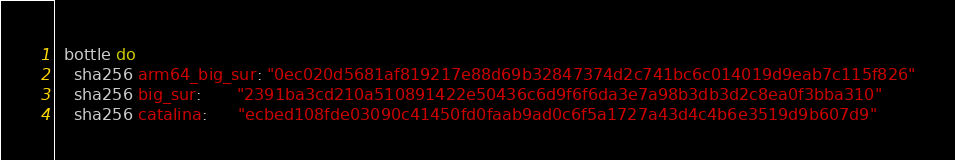<code> <loc_0><loc_0><loc_500><loc_500><_Ruby_>  bottle do
    sha256 arm64_big_sur: "0ec020d5681af819217e88d69b32847374d2c741bc6c014019d9eab7c115f826"
    sha256 big_sur:       "2391ba3cd210a510891422e50436c6d9f6f6da3e7a98b3db3d2c8ea0f3bba310"
    sha256 catalina:      "ecbed108fde03090c41450fd0faab9ad0c6f5a1727a43d4c4b6e3519d9b607d9"</code> 